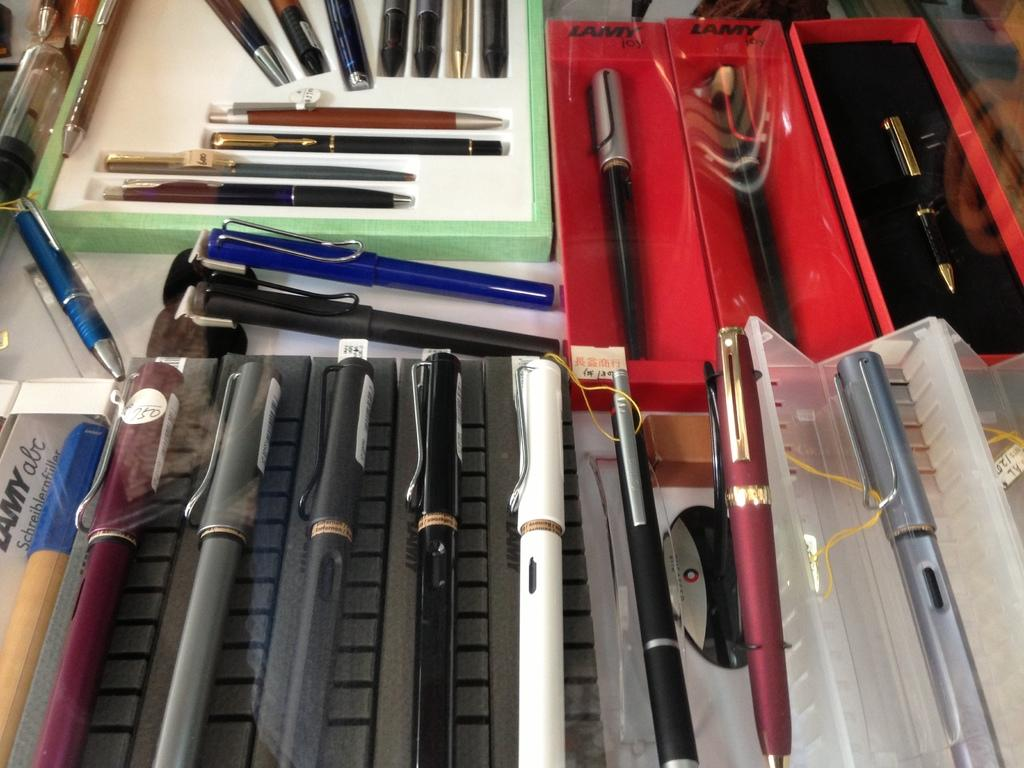What objects are present in the image? There are pens in the image. How are the pens organized or stored? The pens are in boxes. What variety of colors can be seen among the pens? The pens are in multiple colors. What type of punishment is being administered in the image? There is no punishment being administered in the image; it features pens in boxes of multiple colors. 